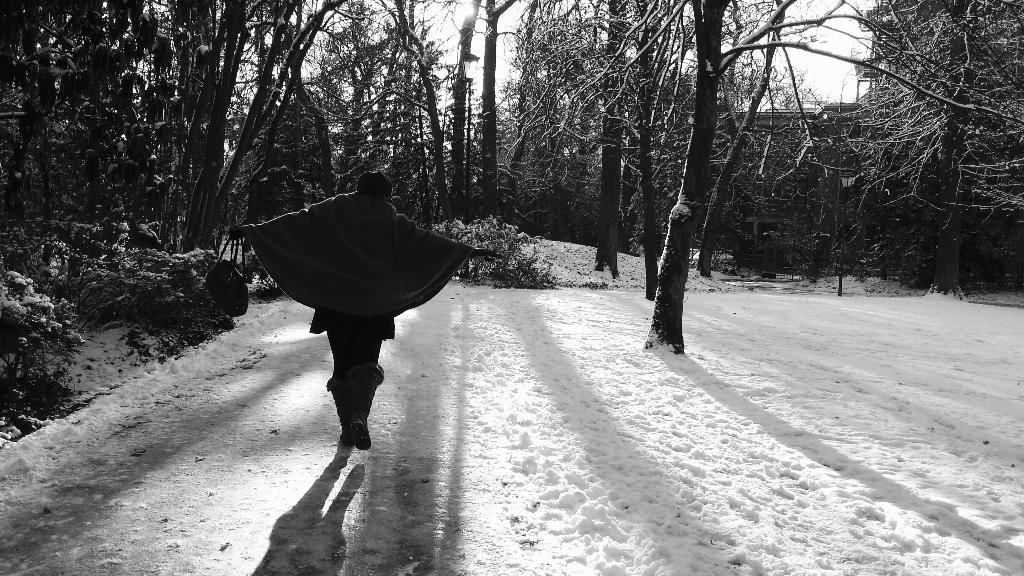What is the color scheme of the image? The image is black and white. What is the person in the image doing? There is a person walking on the road in the image. What is the condition of the ground in the image? There is snow on the road and ground in the image. What can be seen in the background of the image? There are trees, plants, a house, and the sky visible in the background of the image. How many sheep are present in the image? There are no sheep present in the image. What role does the parent play in the image? There is no reference to a parent or any parent-child relationship in the image. 